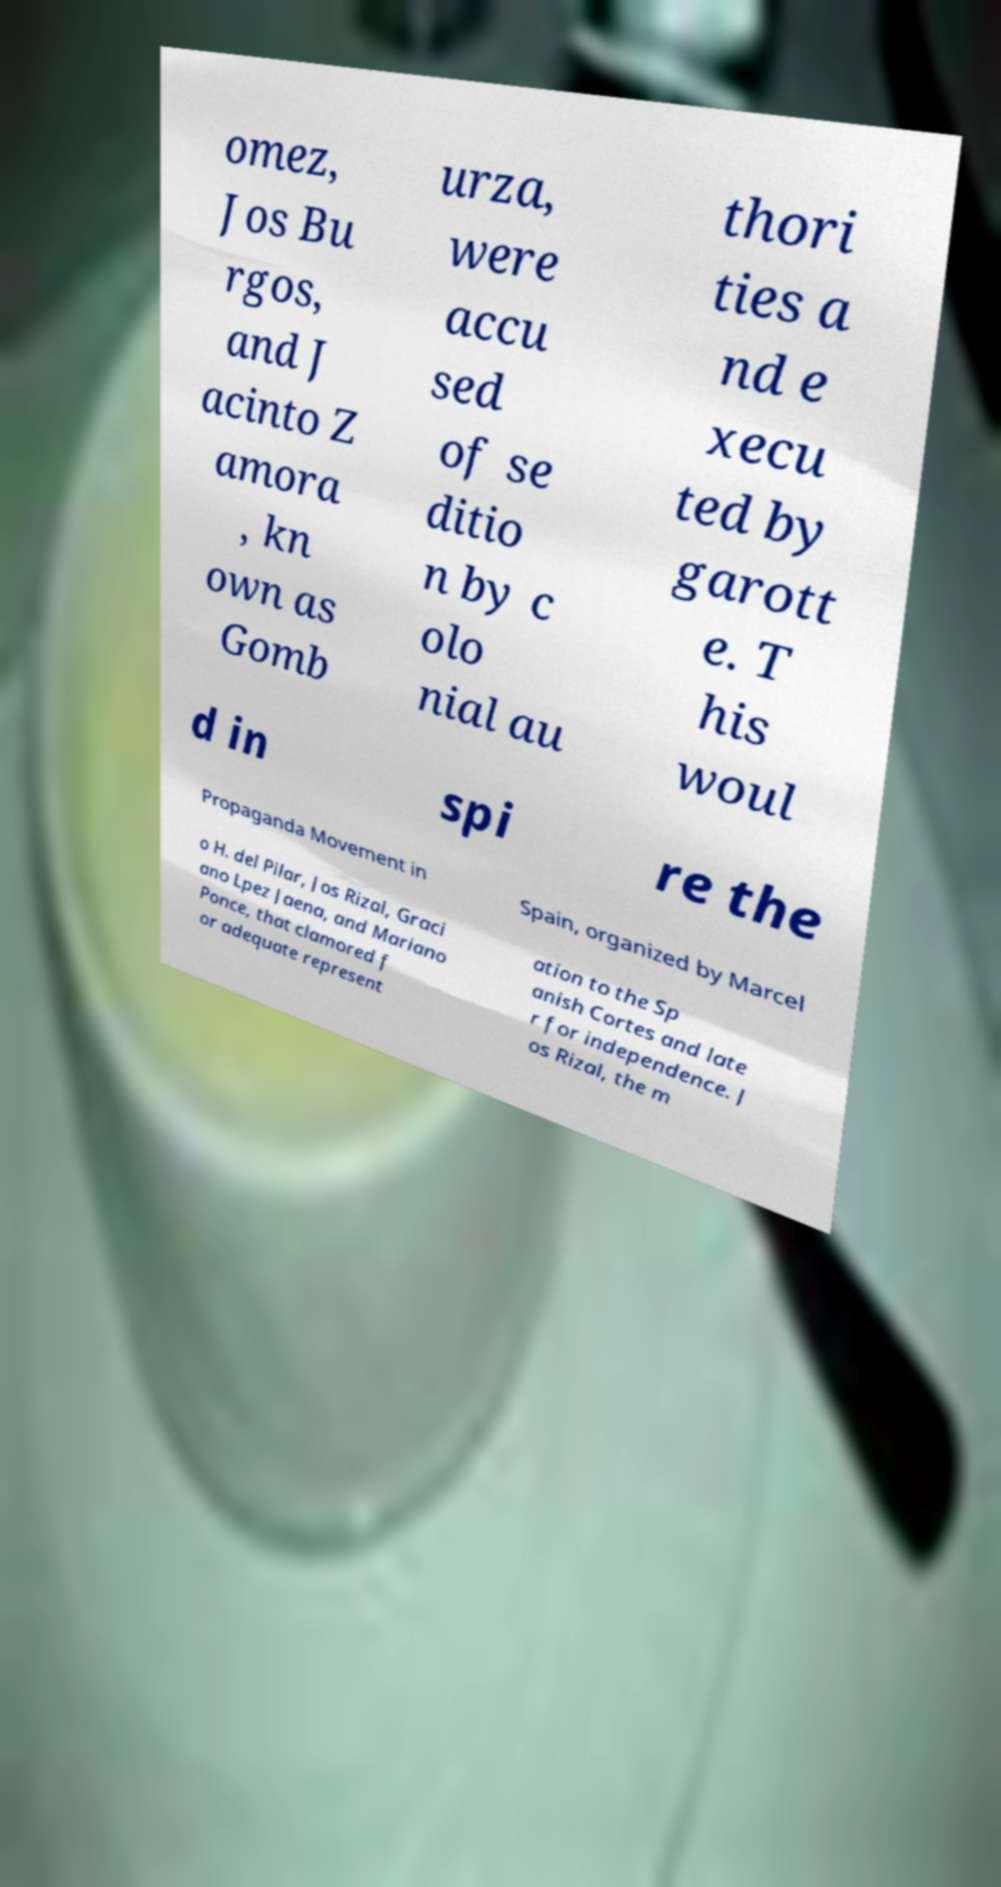There's text embedded in this image that I need extracted. Can you transcribe it verbatim? omez, Jos Bu rgos, and J acinto Z amora , kn own as Gomb urza, were accu sed of se ditio n by c olo nial au thori ties a nd e xecu ted by garott e. T his woul d in spi re the Propaganda Movement in Spain, organized by Marcel o H. del Pilar, Jos Rizal, Graci ano Lpez Jaena, and Mariano Ponce, that clamored f or adequate represent ation to the Sp anish Cortes and late r for independence. J os Rizal, the m 